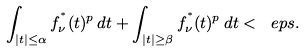<formula> <loc_0><loc_0><loc_500><loc_500>\int _ { | t | \leq \alpha } f _ { \nu } ^ { ^ { * } } ( t ) ^ { p } \, d t + \int _ { | t | \geq \beta } f _ { \nu } ^ { ^ { * } } ( t ) ^ { p } \, d t < \ e p s .</formula> 